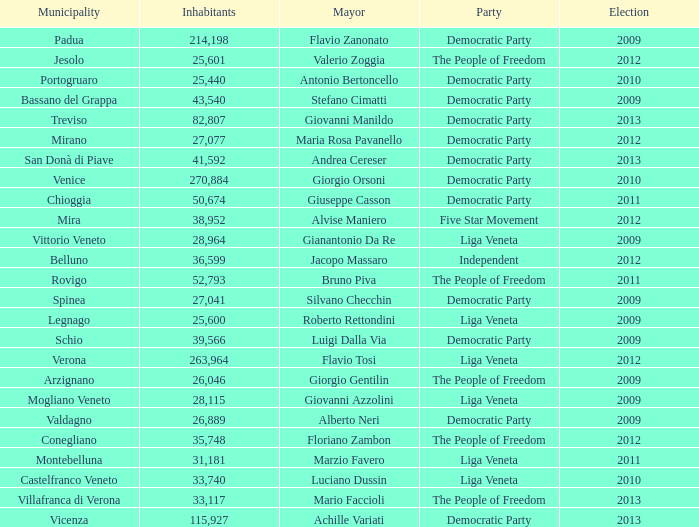In the election earlier than 2012 how many Inhabitants had a Party of five star movement? None. 